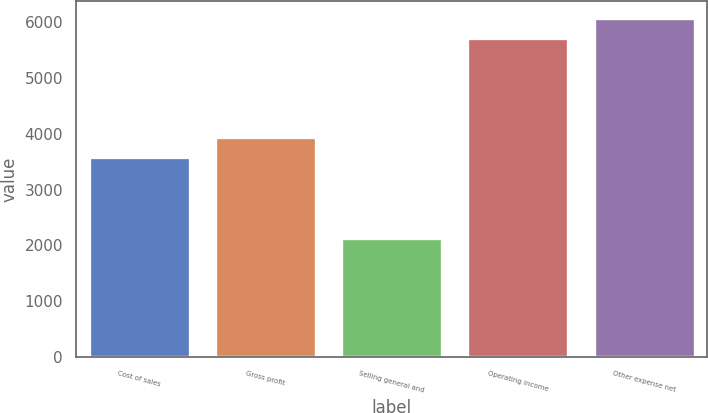Convert chart to OTSL. <chart><loc_0><loc_0><loc_500><loc_500><bar_chart><fcel>Cost of sales<fcel>Gross profit<fcel>Selling general and<fcel>Operating income<fcel>Other expense net<nl><fcel>3576<fcel>3933.6<fcel>2137<fcel>5713<fcel>6070.6<nl></chart> 